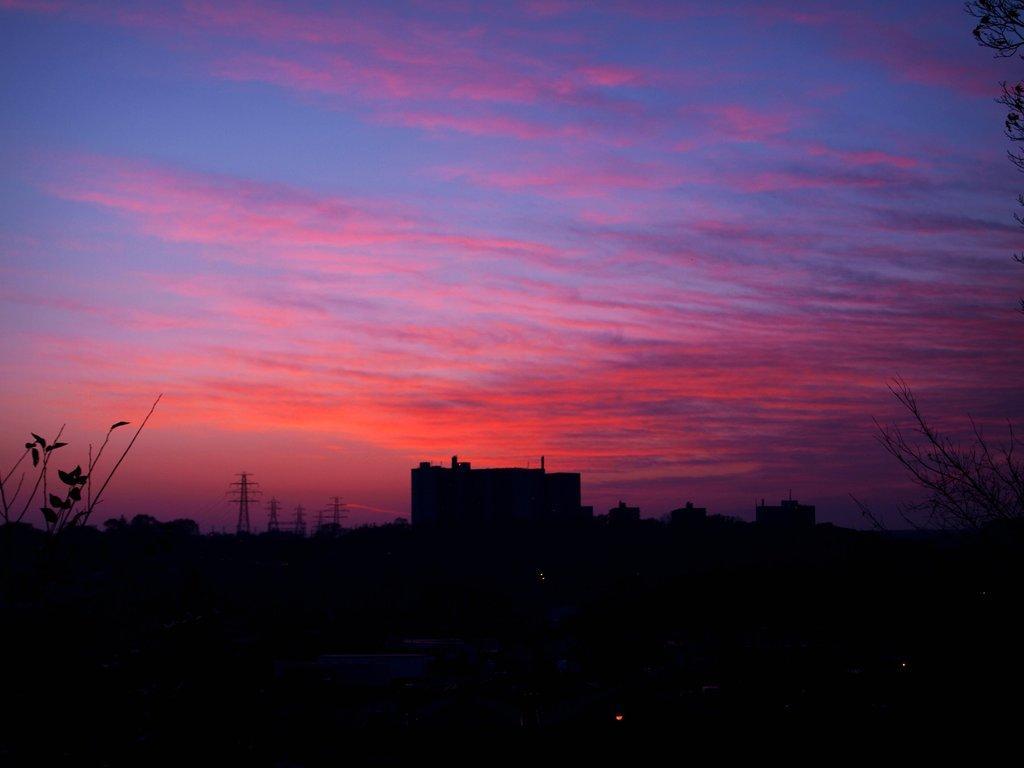Could you give a brief overview of what you see in this image? In this picture I can see trees, these look like buildings , there are cell towers, and in the background there is sky. 